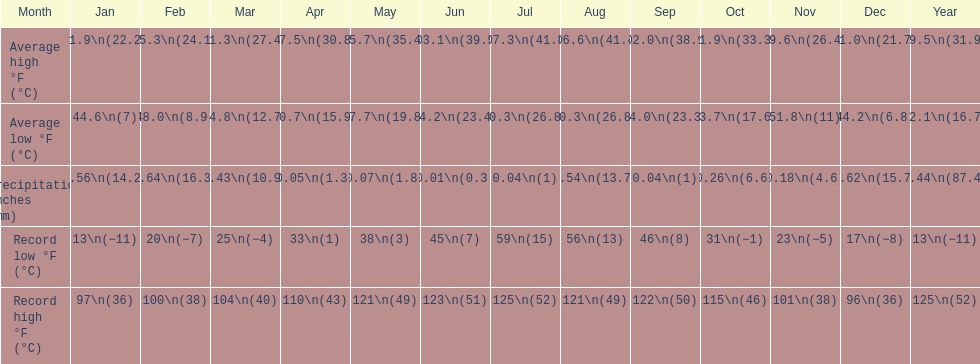How long was the monthly average temperature 100 degrees or more? 4 months. 